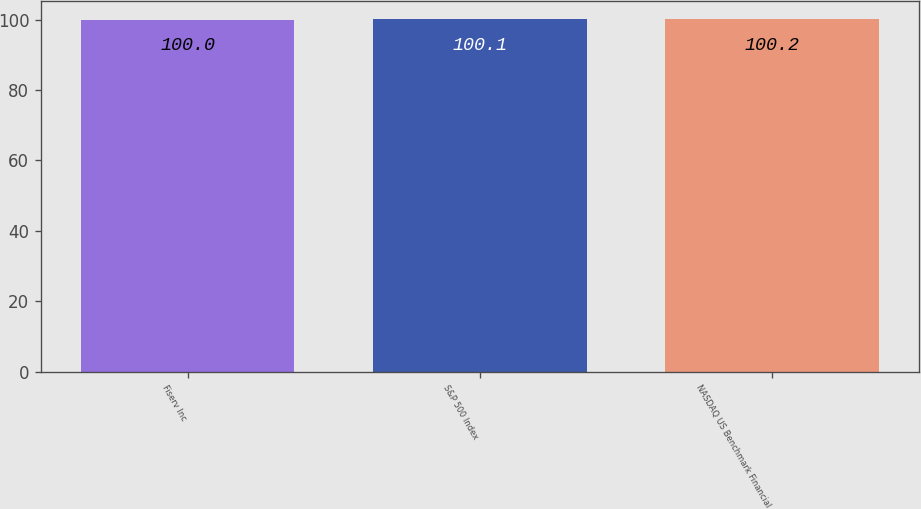Convert chart. <chart><loc_0><loc_0><loc_500><loc_500><bar_chart><fcel>Fiserv Inc<fcel>S&P 500 Index<fcel>NASDAQ US Benchmark Financial<nl><fcel>100<fcel>100.1<fcel>100.2<nl></chart> 